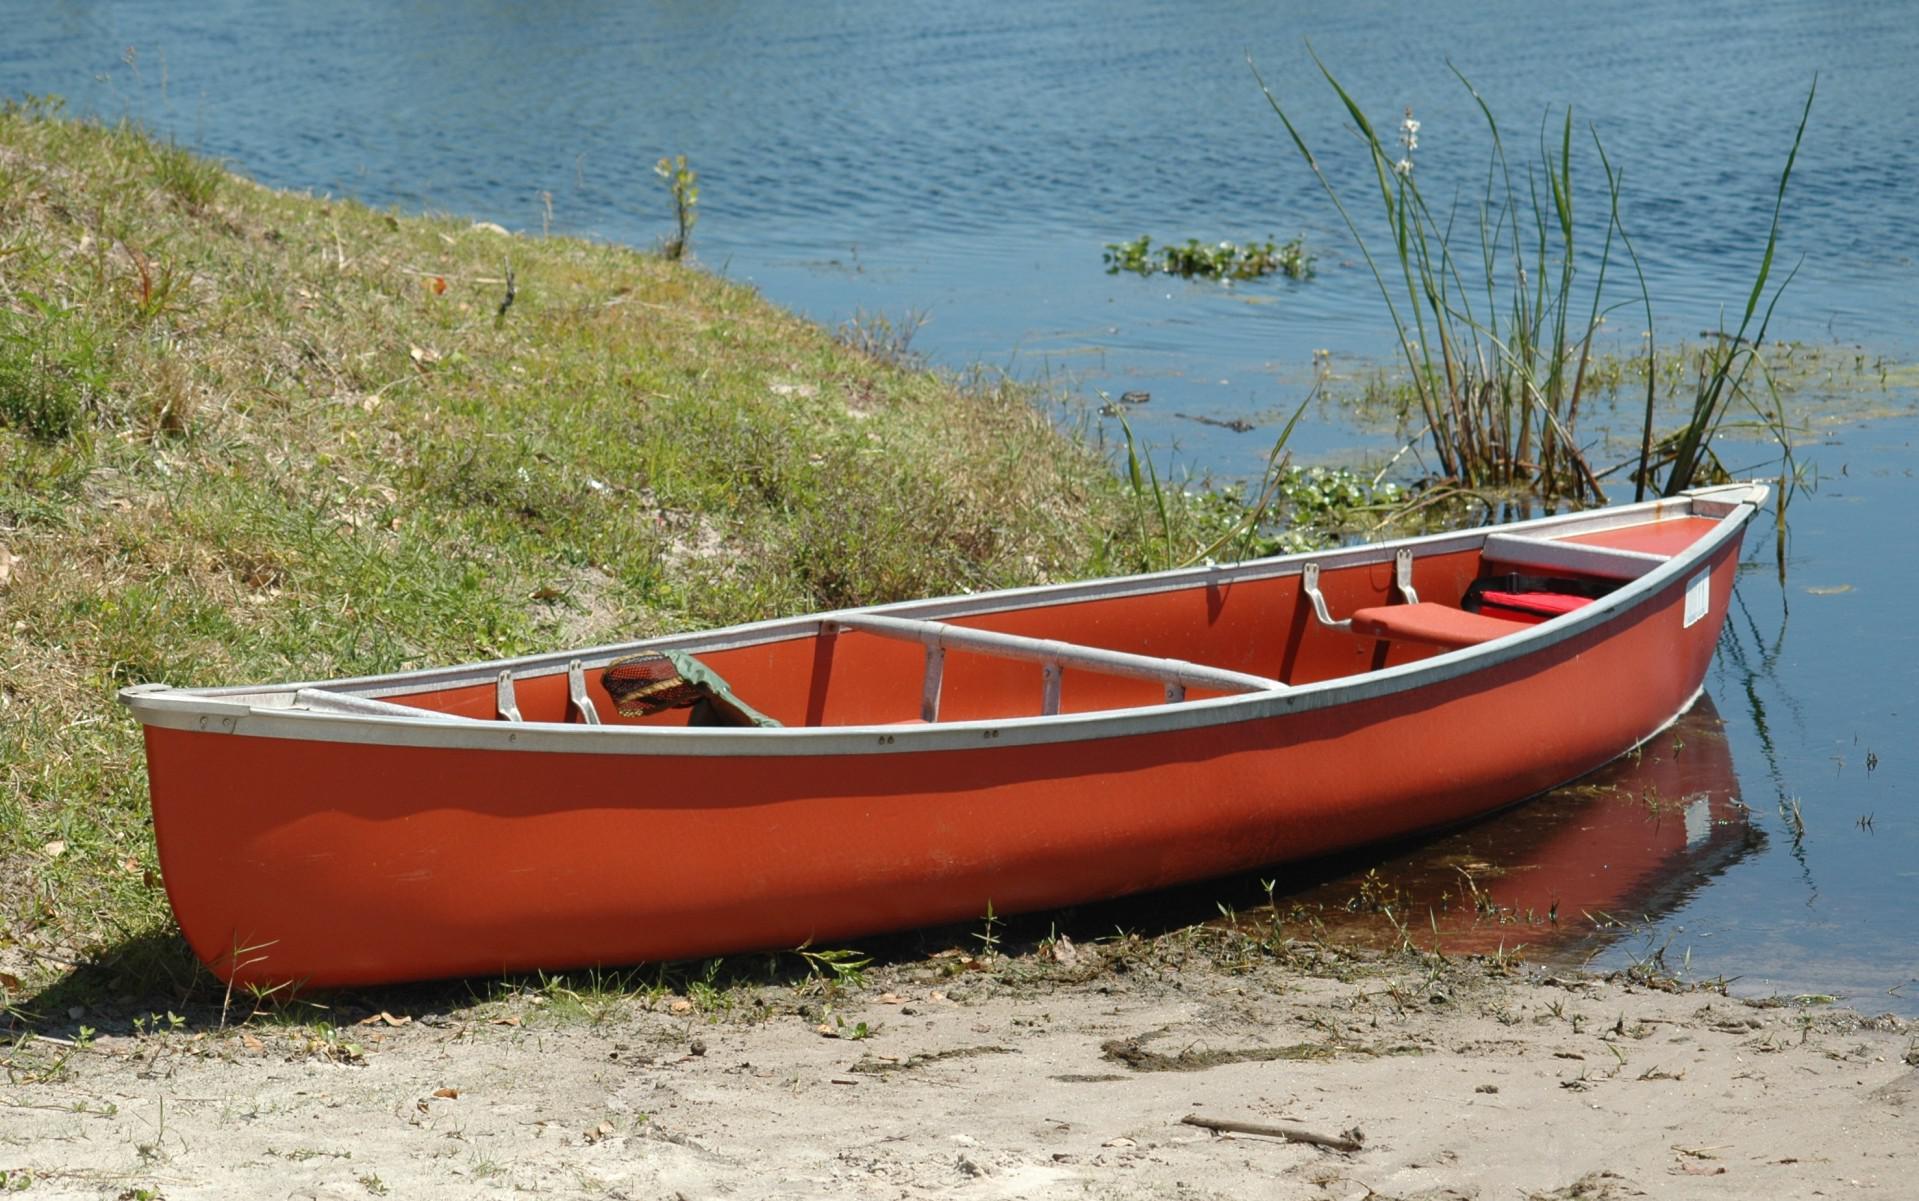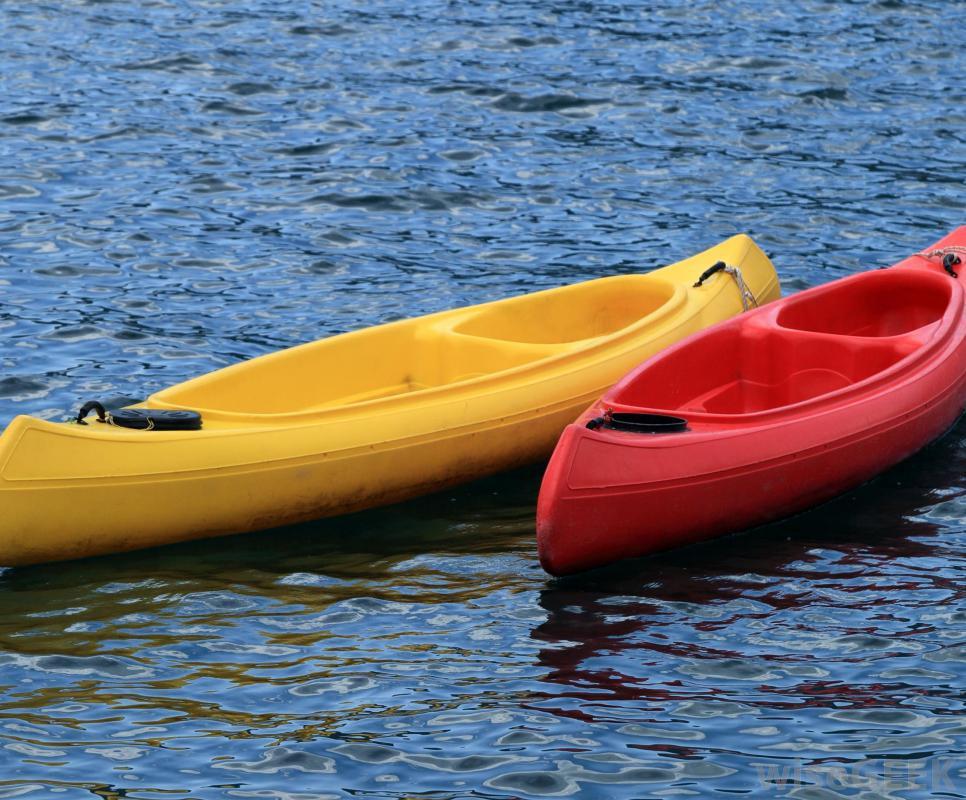The first image is the image on the left, the second image is the image on the right. Examine the images to the left and right. Is the description "In one image a single wooden canoe is angled to show the fine wood grain of its interior, while a second image shows one or more painted canoes on grass." accurate? Answer yes or no. No. The first image is the image on the left, the second image is the image on the right. For the images displayed, is the sentence "An image shows one canoe pulled up to the edge of a body of water." factually correct? Answer yes or no. Yes. 